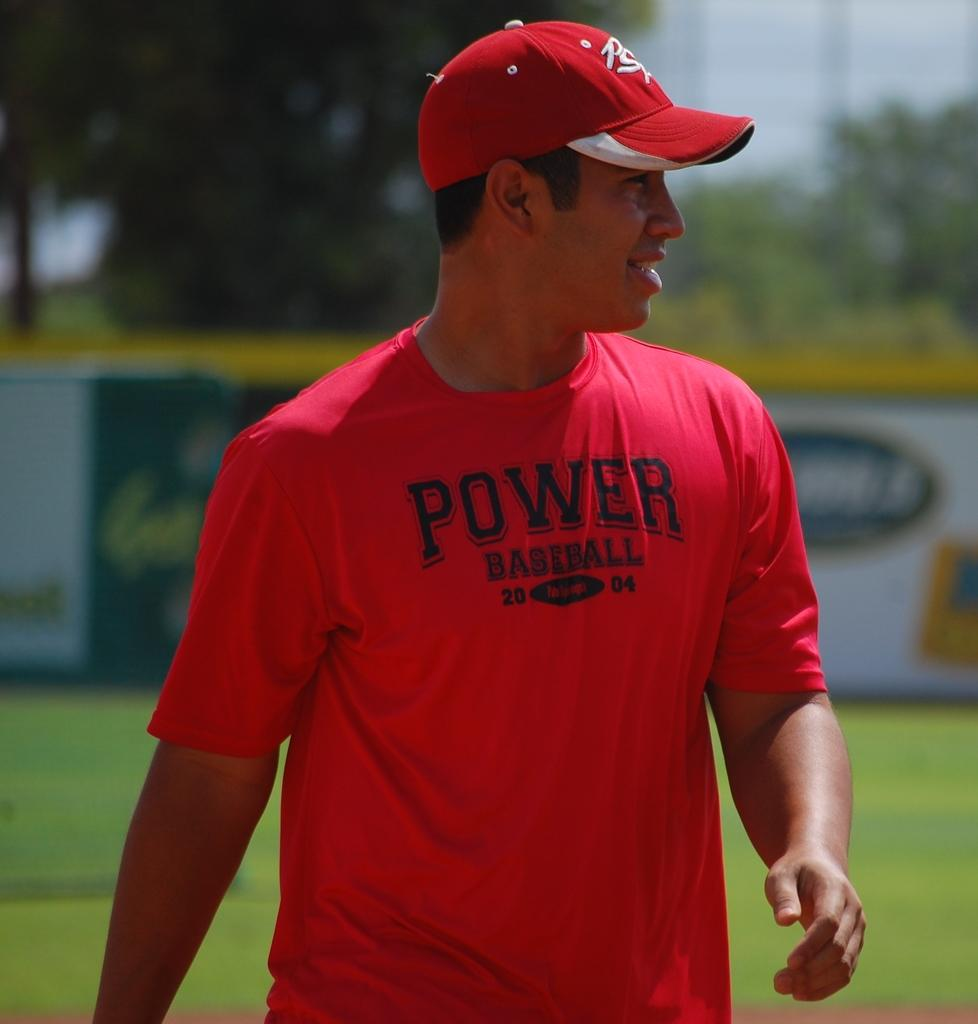<image>
Relay a brief, clear account of the picture shown. A man in a red T-shirt and ball cap is a proponent of Power Baseball. 